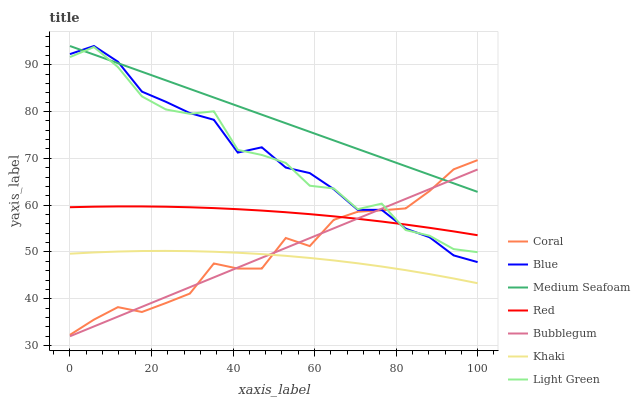Does Khaki have the minimum area under the curve?
Answer yes or no. Yes. Does Medium Seafoam have the maximum area under the curve?
Answer yes or no. Yes. Does Coral have the minimum area under the curve?
Answer yes or no. No. Does Coral have the maximum area under the curve?
Answer yes or no. No. Is Bubblegum the smoothest?
Answer yes or no. Yes. Is Light Green the roughest?
Answer yes or no. Yes. Is Khaki the smoothest?
Answer yes or no. No. Is Khaki the roughest?
Answer yes or no. No. Does Bubblegum have the lowest value?
Answer yes or no. Yes. Does Khaki have the lowest value?
Answer yes or no. No. Does Medium Seafoam have the highest value?
Answer yes or no. Yes. Does Coral have the highest value?
Answer yes or no. No. Is Khaki less than Red?
Answer yes or no. Yes. Is Red greater than Khaki?
Answer yes or no. Yes. Does Red intersect Blue?
Answer yes or no. Yes. Is Red less than Blue?
Answer yes or no. No. Is Red greater than Blue?
Answer yes or no. No. Does Khaki intersect Red?
Answer yes or no. No. 